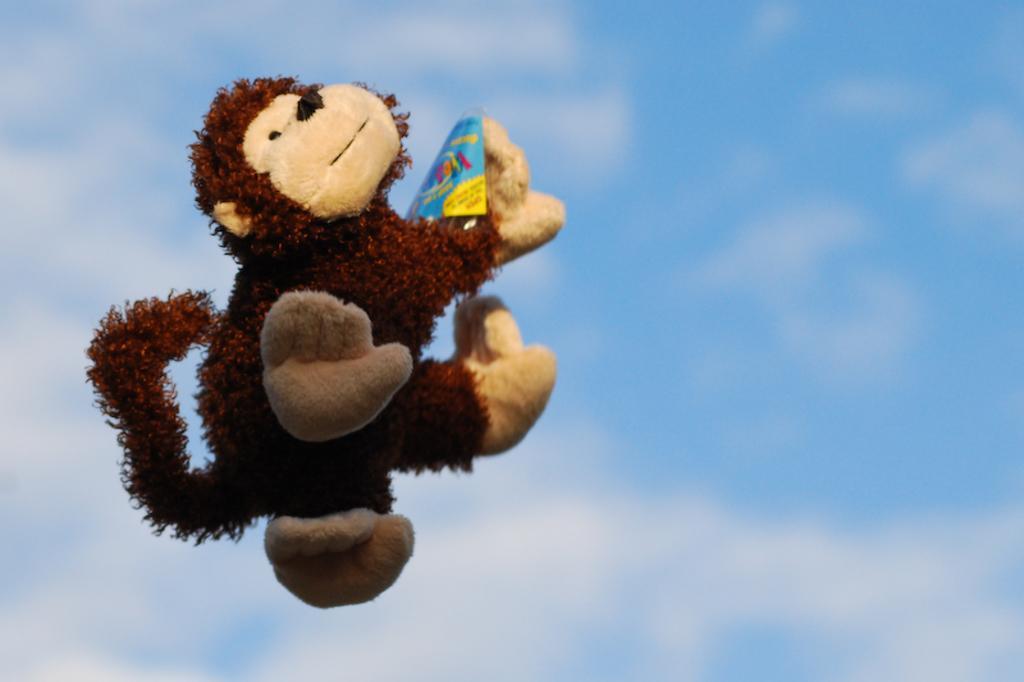Could you give a brief overview of what you see in this image? In this image, we can see a monkey toy in the air. Here we can see colorful object. Background we can see the sky. 